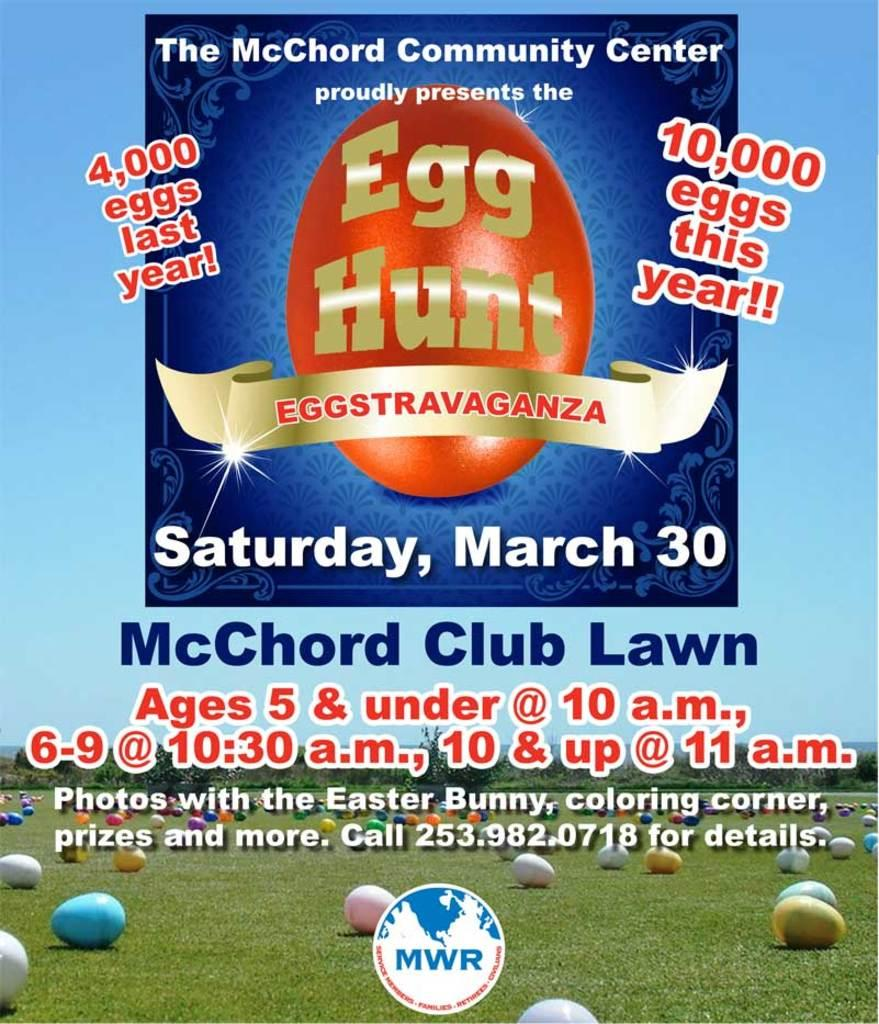<image>
Create a compact narrative representing the image presented. A poster is advertising an Egg Hunt with 10,000 eggs. 